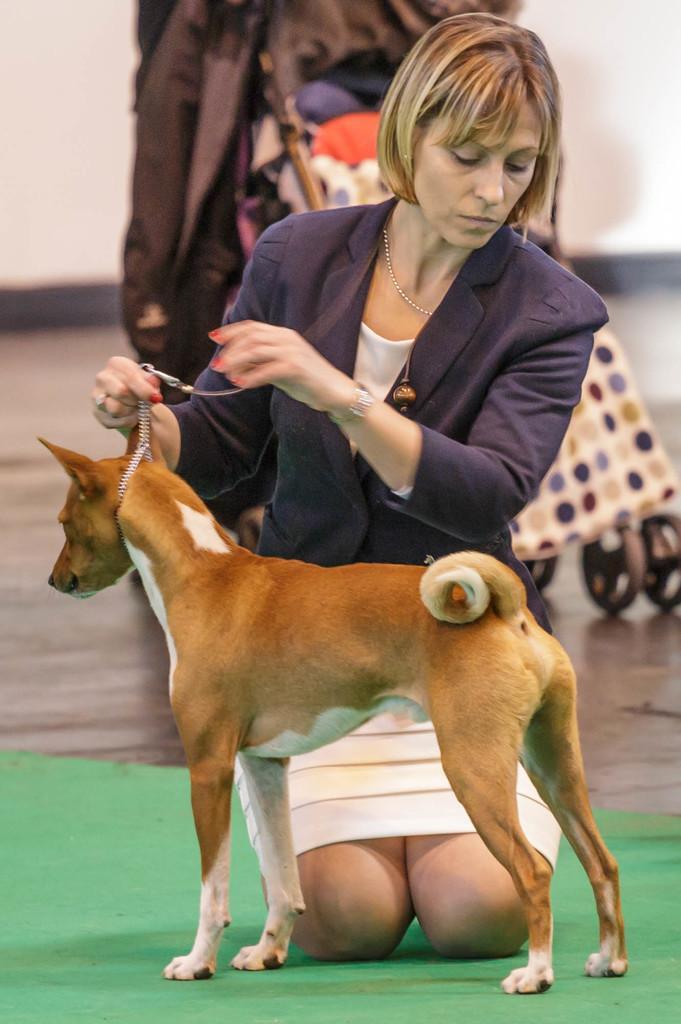In one or two sentences, can you explain what this image depicts? In the picture there is a woman and a dog. The woman is wearing a white dress and a beautiful blue jacket over it. She is holding the dog with the help of chain. There is a carpet on the floor. Behind them there is a trolley and clothes are placed over it. 